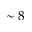Convert formula to latex. <formula><loc_0><loc_0><loc_500><loc_500>\sim 8</formula> 